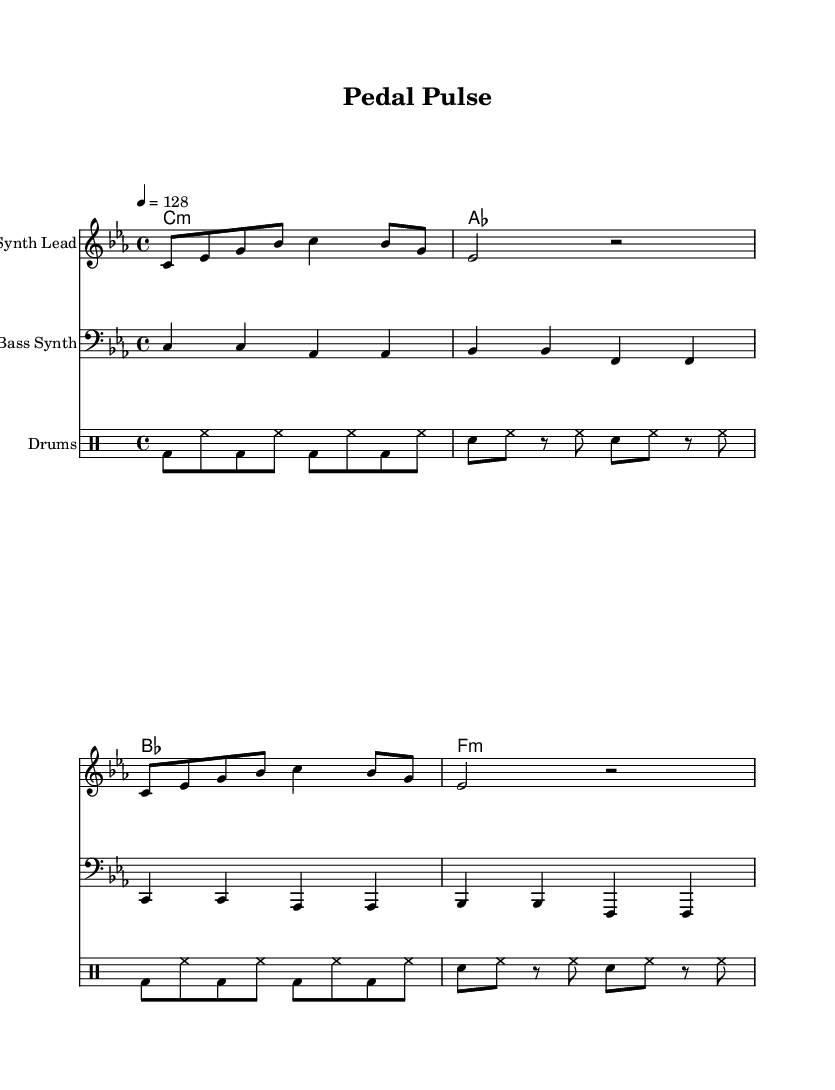What is the key signature of this music? The key signature is C minor, indicated by three flats on the staff.
Answer: C minor What is the time signature of this piece? The time signature is 4/4, which is shown at the beginning of the music.
Answer: 4/4 What is the tempo marking of the piece? The tempo marking indicates a speed of 128 beats per minute, as shown at the start of the score.
Answer: 128 How many measures are in the synth lead part? There are four measures in the synth lead part, as indicated by counting the separated groups of notes.
Answer: 4 What is the primary rhythmic element used in the drum pattern? The drum pattern mainly features a standard kick and snare rhythm with hi-hats, creating a driving beat.
Answer: Kick and snare Which chords are predominantly used throughout the piece? The chords used include C minor, A flat major, B flat major, and F minor, shown in the chord section.
Answer: C minor, A flat, B flat, F minor What is the significance of the tempo marking in relation to cycling? The tempo of 128 beats per minute is conducive to mimicking a cycling cadence, as many cyclists aim for a cadence of 80-100 RPM.
Answer: Mimics cycling cadence 